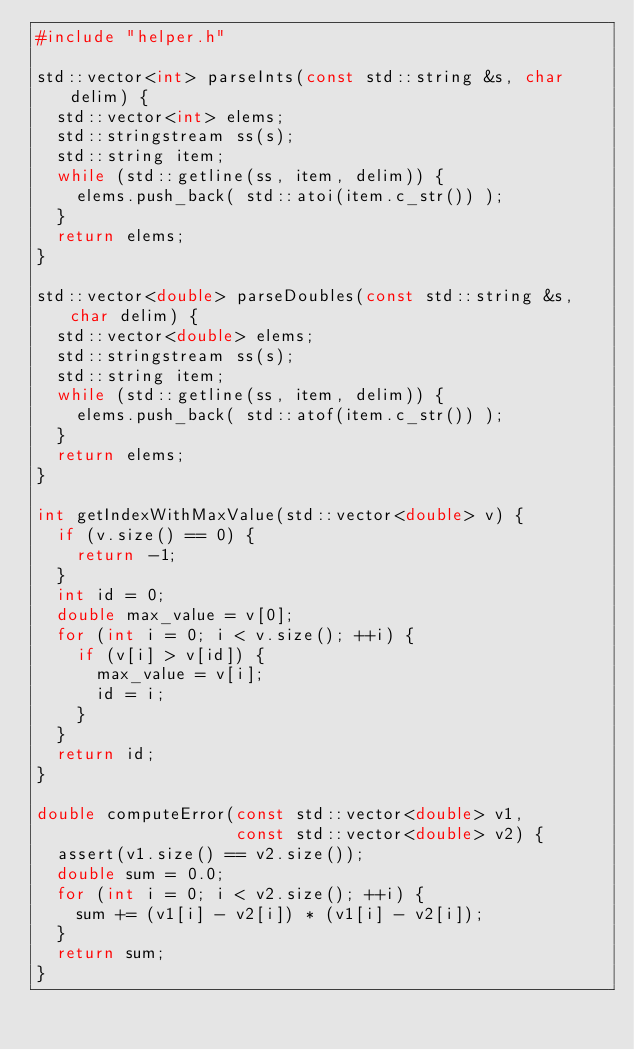Convert code to text. <code><loc_0><loc_0><loc_500><loc_500><_C++_>#include "helper.h"

std::vector<int> parseInts(const std::string &s, char delim) {
  std::vector<int> elems;
  std::stringstream ss(s);
  std::string item;
  while (std::getline(ss, item, delim)) {
    elems.push_back( std::atoi(item.c_str()) );
  }
  return elems;
}

std::vector<double> parseDoubles(const std::string &s, char delim) {
  std::vector<double> elems;
  std::stringstream ss(s);
  std::string item;
  while (std::getline(ss, item, delim)) {
    elems.push_back( std::atof(item.c_str()) );
  }
  return elems;
}

int getIndexWithMaxValue(std::vector<double> v) {
  if (v.size() == 0) {
    return -1;
  }
  int id = 0;
  double max_value = v[0];
  for (int i = 0; i < v.size(); ++i) {
    if (v[i] > v[id]) {
      max_value = v[i];
      id = i;
    }
  }
  return id;
}

double computeError(const std::vector<double> v1,
                    const std::vector<double> v2) {
  assert(v1.size() == v2.size());
  double sum = 0.0;
  for (int i = 0; i < v2.size(); ++i) {
    sum += (v1[i] - v2[i]) * (v1[i] - v2[i]);
  }
  return sum;
}

</code> 